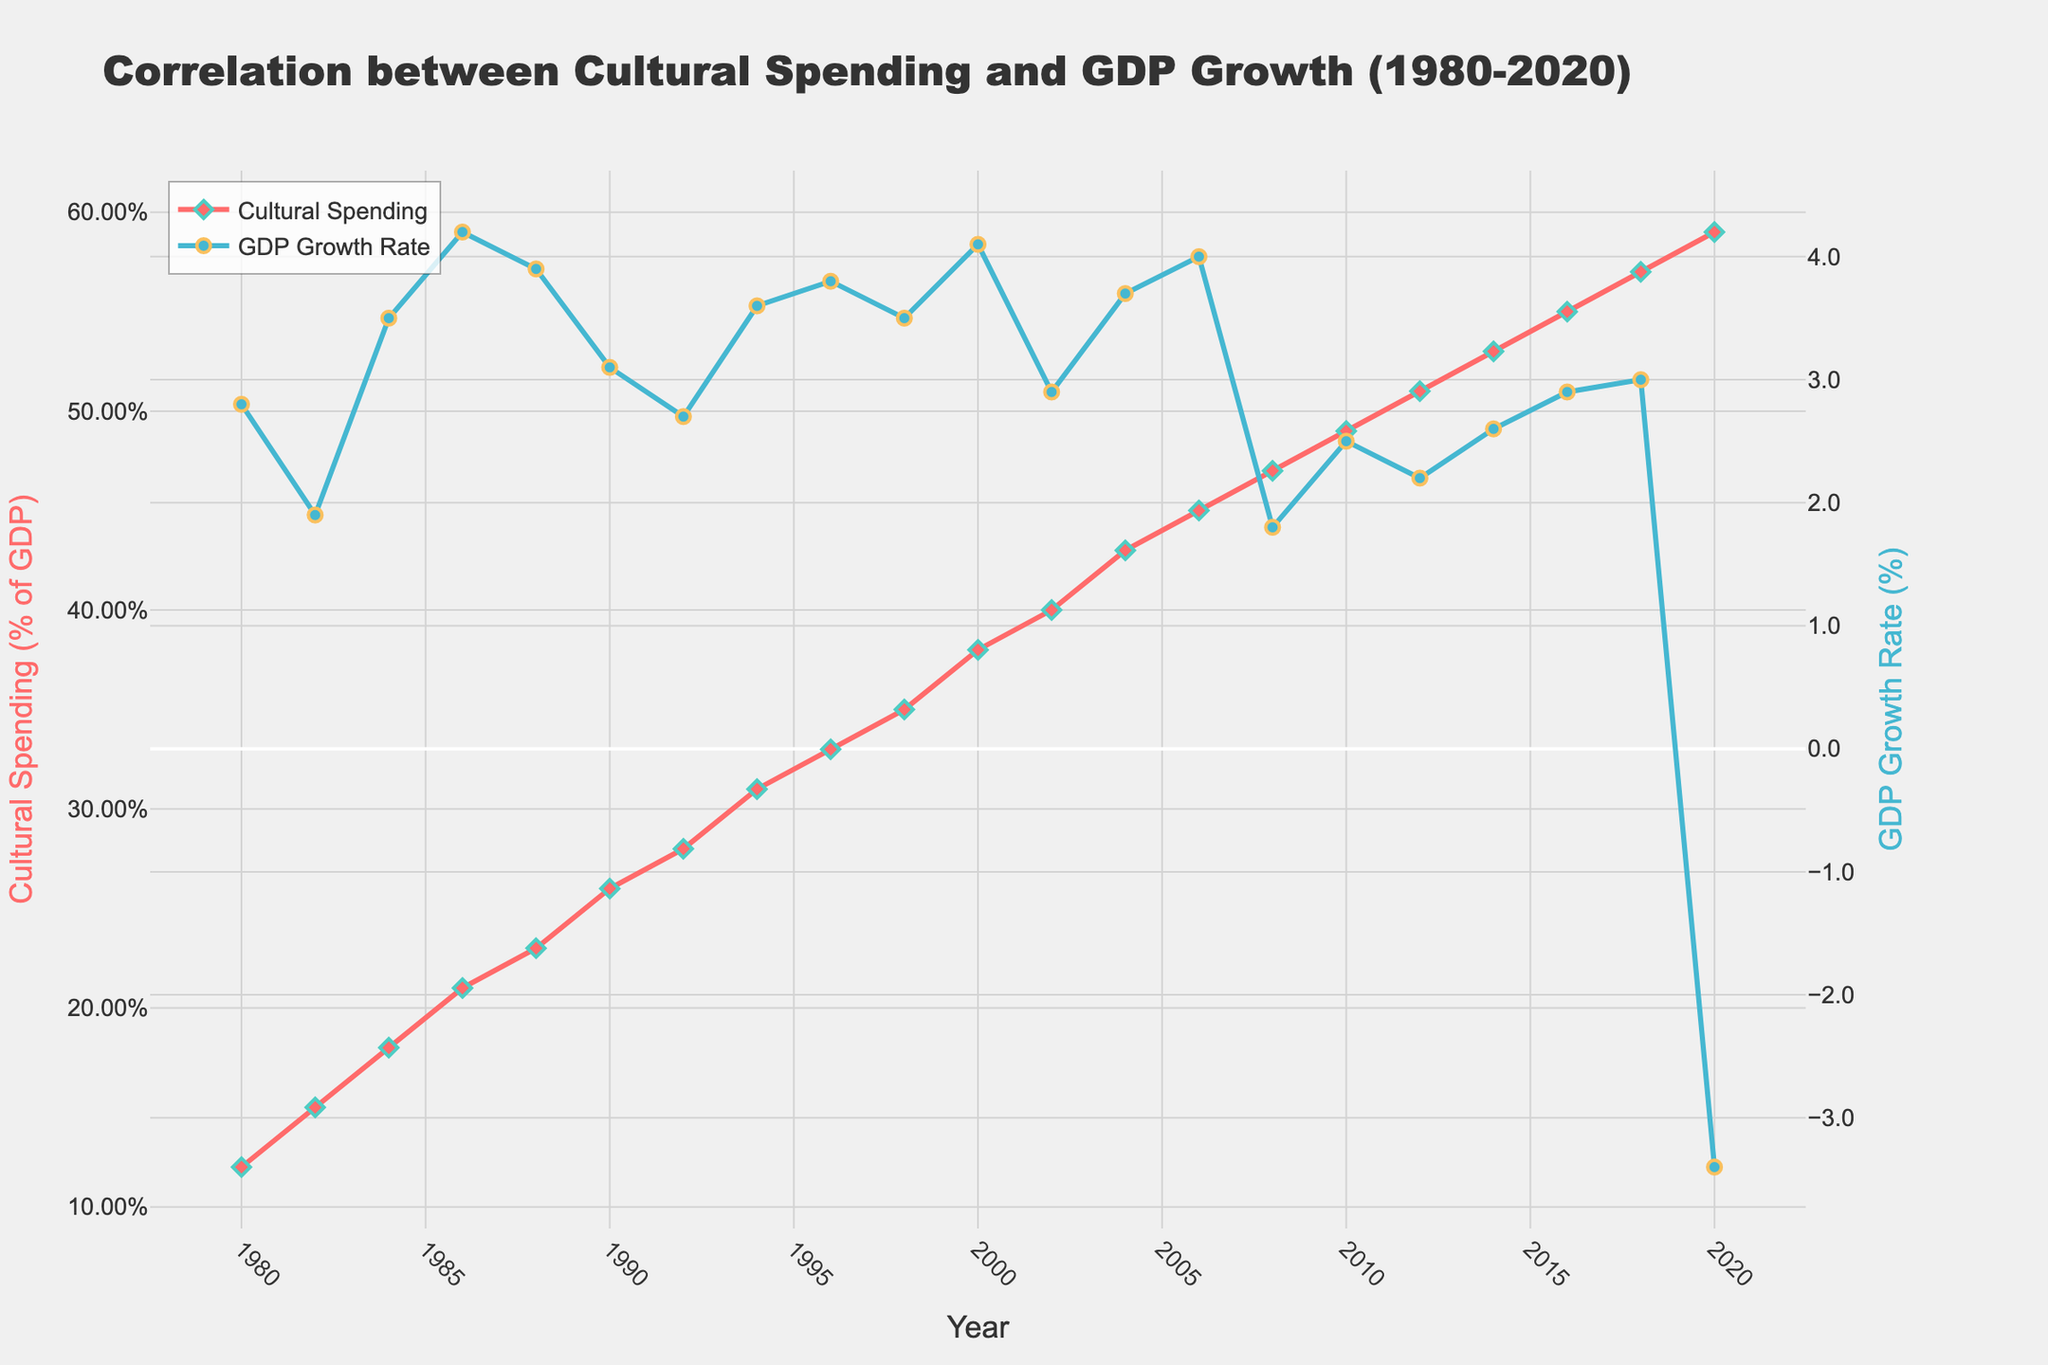What's the trend of government spending on cultural programs from 1980 to 2020? From the figure, we can see that the line representing government spending on cultural programs steadily rises from 1980 to 2020, indicating a continuous increase in spending over time.
Answer: Increasing How did the GDP growth rate change in 2020 compared to previous years? The GDP growth rate significantly dropped in 2020, reaching -3.4%, whereas, in previous years, it mostly remained positive and ranged between 1.8% and 4.2%.
Answer: Significantly decreased Which year had the highest GDP growth rate, and what was it? By observing the peak of the blue line on the GDP growth rate axis, the highest growth rate is seen in 1986, which was 4.2%.
Answer: 1986, 4.2% Between which years did government spending on cultural programs exceed 0.4% of GDP for the first time, and what was the corresponding GDP growth rate at that point? The red line representing government spending exceeds 0.4% of GDP between 2002 and 2004. In 2002, it was 0.40%, and in 2004 it was 0.43%. During this time, the GDP growth rate was 2.9% in 2002 and 3.7% in 2004.
Answer: Between 2002 and 2004; 2002: 2.9%, 2004: 3.7% What is the average government spending on cultural programs from 1980 to 2000? To calculate the average, sum the spending percentages from 1980 (0.12%), 1982 (0.15%), 1984 (0.18%), 1986 (0.21%), 1988 (0.23%), 1990 (0.26%), 1992 (0.28%), 1994 (0.31%), 1996 (0.33%), 1998 (0.35%), and 2000 (0.38%), then divide by the number of years (11). The sum is 1.8, so the average is 1.8 / 11 = 0.1636 or 0.16%.
Answer: 0.16% Compare the GDP growth rates in 1980 and 2020. What do you observe? The GDP growth rate was 2.8% in 1980, whereas in 2020, it was -3.4%. This indicates a considerable decline from 1980 to 2020.
Answer: Considerable decline Which year marked the first time government spending on cultural programs reached or exceeded 0.5% of GDP, and what was the GDP growth rate that year? The first year government spending reached 0.5% was 2012. The GDP growth rate for that year was 2.2%.
Answer: 2012; 2.2% During which periods did the GDP growth rate show a significant decline while government spending on cultural programs continued to rise? Significant declines in GDP growth rates are noticeable around 2008 (financial crisis) and 2020 (pandemic). Despite government spending on cultural programs progressively rising during these periods, the GDP growth rate dropped to 1.8% in 2008 and -3.4% in 2020.
Answer: 2008 and 2020 What is the total increase in government spending on cultural programs from 1980 to 2020? The increase is the difference between the spending percentage in 2020 and 1980. In 2020, it was 0.59%, and in 1980, it was 0.12%. Thus, the increase is 0.59% - 0.12% = 0.47%.
Answer: 0.47% 